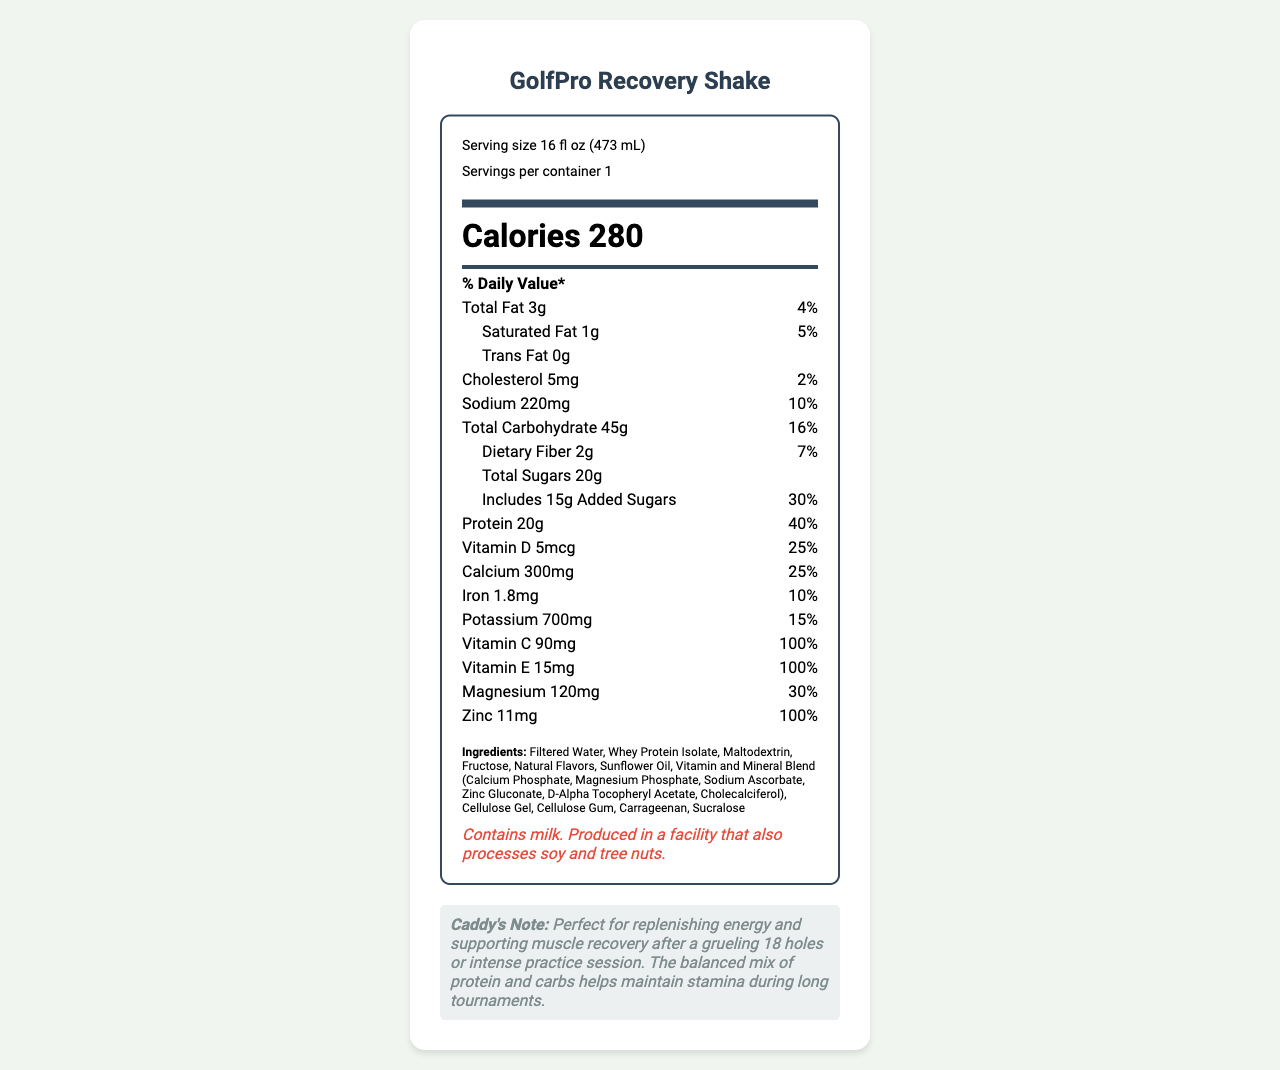what is the serving size? The serving size is mentioned right below the product name and servings per container at the top of the label.
Answer: 16 fl oz (473 mL) how many calories are in one serving? The number of calories is displayed prominently in large font in the middle of the label.
Answer: 280 what is the amount of protein in the shake? The protein amount is listed in the nutrients section, with both the amount and the daily value percentage.
Answer: 20g what is the percentage of daily value for dietary fiber? The daily value percentage for dietary fiber is shown next to its amount in the nutrients section.
Answer: 7% how much total fat is in the shake? The total fat is listed with its amount and daily value percentage in the nutrient details.
Answer: 3g which vitamin has the highest daily value percentage? A. Vitamin D B. Vitamin C C. Vitamin E D. Vitamin B12 Vitamin C has a daily value percentage of 100%, which is higher than the other vitamins listed.
Answer: B what is the amount of calcium per serving? The amount of calcium is listed in the nutrients section along with its daily value percentage.
Answer: 300mg how much sodium does the shake contain? Sodium content is shown in the nutrient information with its corresponding daily value percentage.
Answer: 220mg what are the first three ingredients listed? Ingredients are listed in descending order by weight, with the first three specified at the beginning.
Answer: Filtered Water, Whey Protein Isolate, Maltodextrin what does the caddy note suggest about the shake? The caddy note at the bottom of the document provides this information.
Answer: Perfect for replenishing energy and supporting muscle recovery after a grueling 18 holes or intense practice session. does the shake contain any trans fat? The trans fat content is listed as 0g in the nutrients section.
Answer: No what is the source of Vitamin E in the ingredients? The vitamin and mineral blend in the ingredients list specifies D-Alpha Tocopheryl Acetate as the source of Vitamin E.
Answer: D-Alpha Tocopheryl Acetate how many grams of added sugars are in the shake? The amount of added sugars is listed directly under total sugars in the nutrients section.
Answer: 15g can you determine the price of the shake from the document? The document does not provide any information related to the price of the shake.
Answer: Cannot be determined describe the main idea of the document. The document is focused on showcasing the nutrition facts and benefits of consuming the GolfPro Recovery Shake. The detailed list of ingredients, nutrients, and vitamins, along with the caddy’s note, aims to inform the consumer about its effectiveness in aiding recovery and maintaining stamina during prolonged physical activity.
Answer: The document provides detailed nutritional information about the GolfPro Recovery Shake, a vitamin-fortified beverage designed to support energy replenishment and muscle recovery. It lists the serving size, calorie content, amounts of various nutrients, vitamins, and minerals, as well as the ingredients and allergen information. Additionally, it includes a note emphasizing its benefits for energy and muscle recovery after a long day of golfing. 